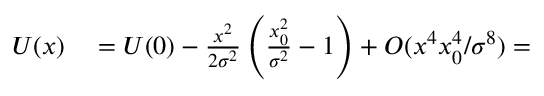Convert formula to latex. <formula><loc_0><loc_0><loc_500><loc_500>\begin{array} { r l } { U ( x ) } & = U ( 0 ) - \frac { x ^ { 2 } } { 2 \sigma ^ { 2 } } \left ( \frac { x _ { 0 } ^ { 2 } } { \sigma ^ { 2 } } - 1 \right ) + O ( x ^ { 4 } x _ { 0 } ^ { 4 } / \sigma ^ { 8 } ) = } \end{array}</formula> 